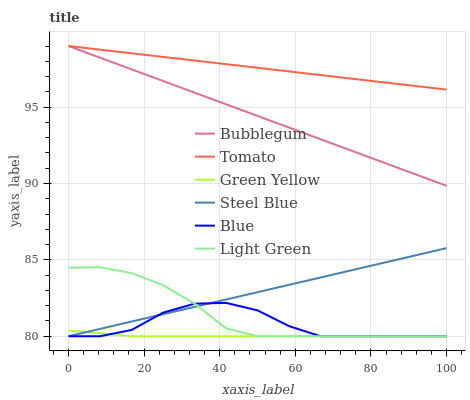Does Green Yellow have the minimum area under the curve?
Answer yes or no. Yes. Does Tomato have the maximum area under the curve?
Answer yes or no. Yes. Does Blue have the minimum area under the curve?
Answer yes or no. No. Does Blue have the maximum area under the curve?
Answer yes or no. No. Is Tomato the smoothest?
Answer yes or no. Yes. Is Blue the roughest?
Answer yes or no. Yes. Is Steel Blue the smoothest?
Answer yes or no. No. Is Steel Blue the roughest?
Answer yes or no. No. Does Bubblegum have the lowest value?
Answer yes or no. No. Does Bubblegum have the highest value?
Answer yes or no. Yes. Does Blue have the highest value?
Answer yes or no. No. Is Light Green less than Tomato?
Answer yes or no. Yes. Is Bubblegum greater than Blue?
Answer yes or no. Yes. Does Blue intersect Light Green?
Answer yes or no. Yes. Is Blue less than Light Green?
Answer yes or no. No. Is Blue greater than Light Green?
Answer yes or no. No. Does Light Green intersect Tomato?
Answer yes or no. No. 